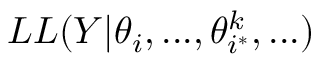Convert formula to latex. <formula><loc_0><loc_0><loc_500><loc_500>L L ( Y | \theta _ { i } , \dots , \theta _ { i ^ { * } } ^ { k } , \dots )</formula> 